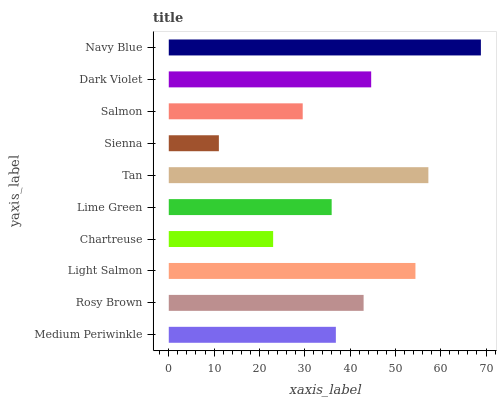Is Sienna the minimum?
Answer yes or no. Yes. Is Navy Blue the maximum?
Answer yes or no. Yes. Is Rosy Brown the minimum?
Answer yes or no. No. Is Rosy Brown the maximum?
Answer yes or no. No. Is Rosy Brown greater than Medium Periwinkle?
Answer yes or no. Yes. Is Medium Periwinkle less than Rosy Brown?
Answer yes or no. Yes. Is Medium Periwinkle greater than Rosy Brown?
Answer yes or no. No. Is Rosy Brown less than Medium Periwinkle?
Answer yes or no. No. Is Rosy Brown the high median?
Answer yes or no. Yes. Is Medium Periwinkle the low median?
Answer yes or no. Yes. Is Navy Blue the high median?
Answer yes or no. No. Is Dark Violet the low median?
Answer yes or no. No. 